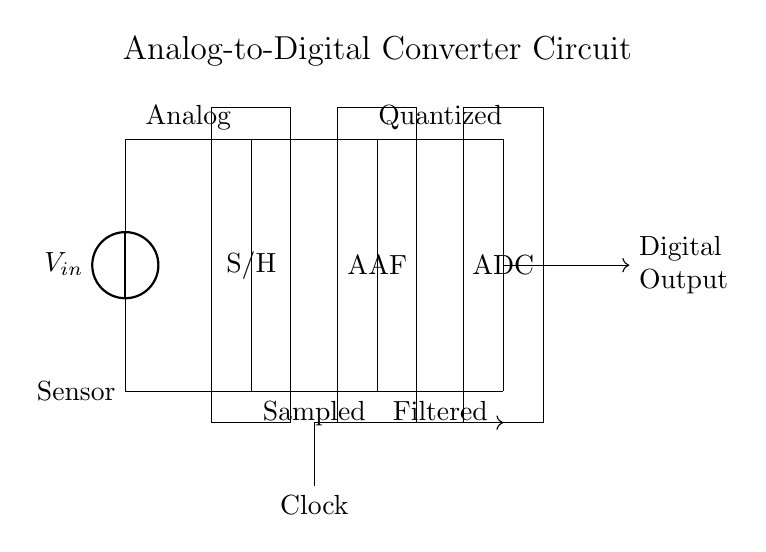What is the function of the S/H component? The S/H component stands for Sample and Hold, which captures and holds the analog voltage from the sensor for a brief time to allow the ADC to convert it into a digital signal.
Answer: Sample and Hold What type of filter is used in this circuit? The circuit includes an Anti-aliasing Filter (AAF), which is used to eliminate high-frequency components from the signal before sampling, preventing aliasing during the ADC conversion process.
Answer: Anti-aliasing Filter What is the role of the Clock in this circuit? The Clock provides timing signals necessary for the ADC to perform conversions at the correct rate, ensuring synchronized operation between the sampling and digitizing processes.
Answer: Timing signals Which component receives the output from the AAF? The ADC receives the output from the Anti-aliasing Filter, where it converts the filtered analog signal into a digital signal for further processing.
Answer: ADC What does the Digital Output represent? The Digital Output represents the final quantized data produced by the ADC after converting the sampled analog signal into a digital format suitable for algorithm analysis.
Answer: Quantized data How many main components are visible in the circuit diagram? The circuit diagram displays four main components, which are the Sensor, Sample and Hold, Anti-aliasing Filter, and ADC.
Answer: Four What is the first stage of conversion in this diagram? The first stage of conversion is the Sample and Hold (S/H), which samples the analog signal from the Sensor and holds it steady for the Analog-to-Digital Converter (ADC) to process.
Answer: Sample and Hold 